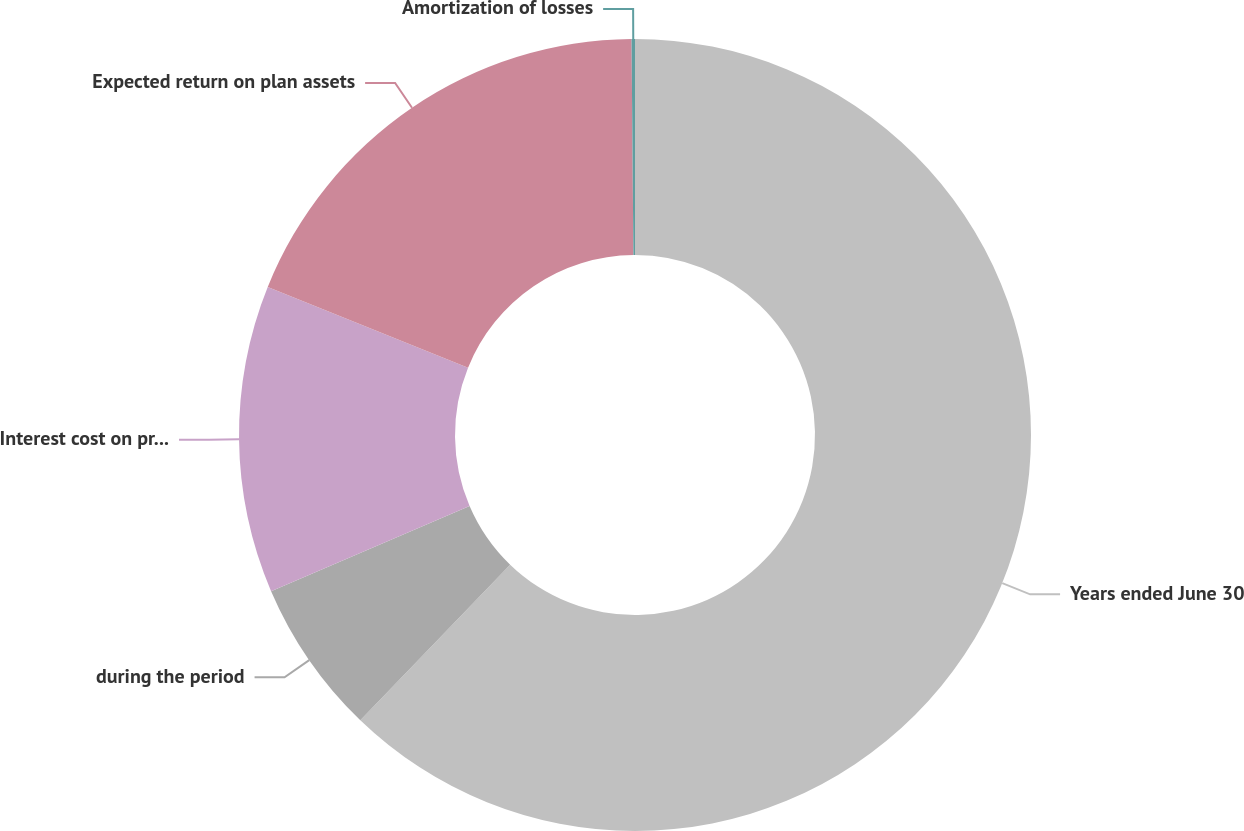<chart> <loc_0><loc_0><loc_500><loc_500><pie_chart><fcel>Years ended June 30<fcel>during the period<fcel>Interest cost on projected<fcel>Expected return on plan assets<fcel>Amortization of losses<nl><fcel>62.2%<fcel>6.35%<fcel>12.55%<fcel>18.76%<fcel>0.14%<nl></chart> 